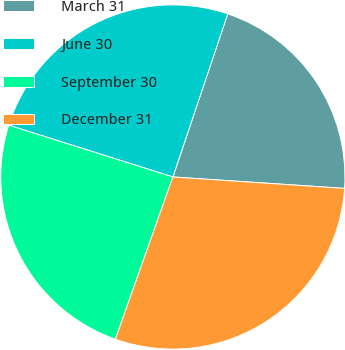Convert chart. <chart><loc_0><loc_0><loc_500><loc_500><pie_chart><fcel>March 31<fcel>June 30<fcel>September 30<fcel>December 31<nl><fcel>20.89%<fcel>25.3%<fcel>24.45%<fcel>29.36%<nl></chart> 